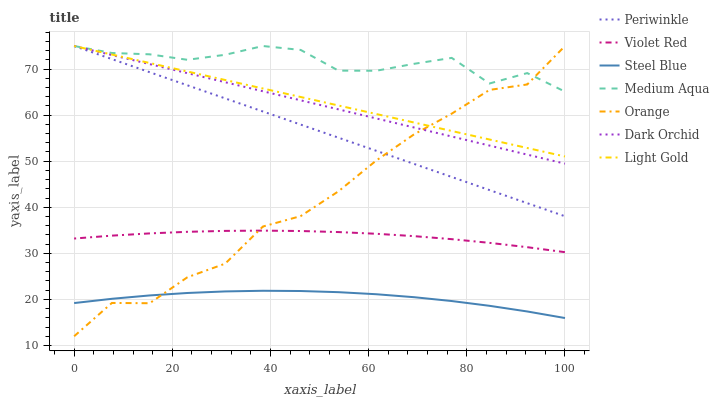Does Steel Blue have the minimum area under the curve?
Answer yes or no. Yes. Does Medium Aqua have the maximum area under the curve?
Answer yes or no. Yes. Does Dark Orchid have the minimum area under the curve?
Answer yes or no. No. Does Dark Orchid have the maximum area under the curve?
Answer yes or no. No. Is Periwinkle the smoothest?
Answer yes or no. Yes. Is Orange the roughest?
Answer yes or no. Yes. Is Steel Blue the smoothest?
Answer yes or no. No. Is Steel Blue the roughest?
Answer yes or no. No. Does Orange have the lowest value?
Answer yes or no. Yes. Does Steel Blue have the lowest value?
Answer yes or no. No. Does Light Gold have the highest value?
Answer yes or no. Yes. Does Steel Blue have the highest value?
Answer yes or no. No. Is Steel Blue less than Violet Red?
Answer yes or no. Yes. Is Medium Aqua greater than Violet Red?
Answer yes or no. Yes. Does Orange intersect Violet Red?
Answer yes or no. Yes. Is Orange less than Violet Red?
Answer yes or no. No. Is Orange greater than Violet Red?
Answer yes or no. No. Does Steel Blue intersect Violet Red?
Answer yes or no. No. 